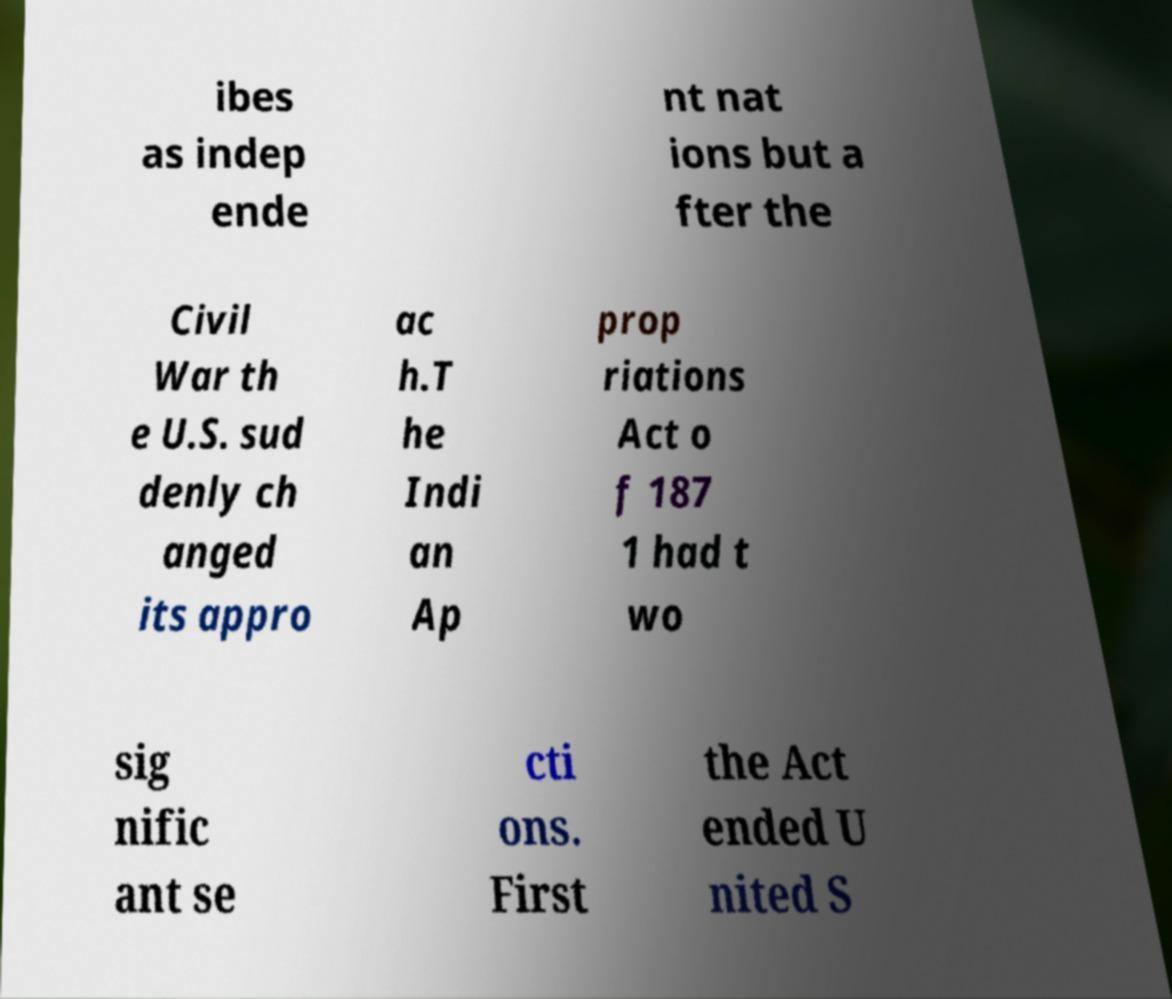Please read and relay the text visible in this image. What does it say? ibes as indep ende nt nat ions but a fter the Civil War th e U.S. sud denly ch anged its appro ac h.T he Indi an Ap prop riations Act o f 187 1 had t wo sig nific ant se cti ons. First the Act ended U nited S 